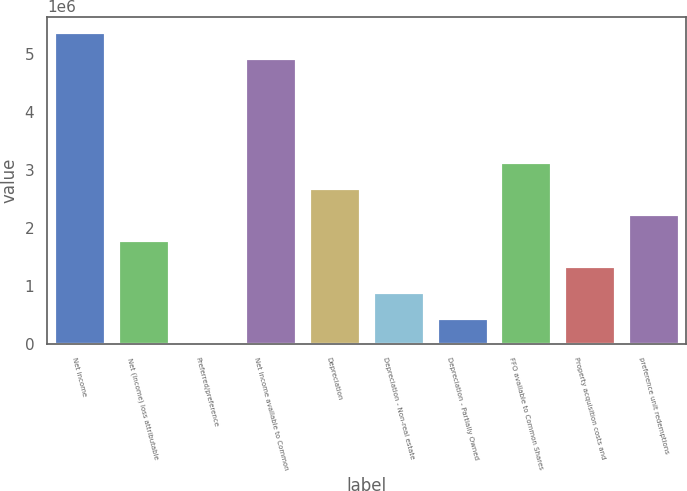Convert chart. <chart><loc_0><loc_0><loc_500><loc_500><bar_chart><fcel>Net income<fcel>Net (income) loss attributable<fcel>Preferred/preference<fcel>Net income available to Common<fcel>Depreciation<fcel>Depreciation - Non-real estate<fcel>Depreciation - Partially Owned<fcel>FFO available to Common Shares<fcel>Property acquisition costs and<fcel>preference unit redemptions<nl><fcel>5.37551e+06<fcel>1.7939e+06<fcel>3091<fcel>4.92781e+06<fcel>2.6893e+06<fcel>898494<fcel>450792<fcel>3.137e+06<fcel>1.34619e+06<fcel>2.2416e+06<nl></chart> 